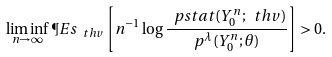<formula> <loc_0><loc_0><loc_500><loc_500>\liminf _ { n \to \infty } \P E s _ { \ t h v } \left [ n ^ { - 1 } \log \frac { \ p s t a t ( Y _ { 0 } ^ { n } ; \ t h v ) } { p ^ { \lambda } ( Y _ { 0 } ^ { n } ; \theta ) } \right ] > 0 .</formula> 